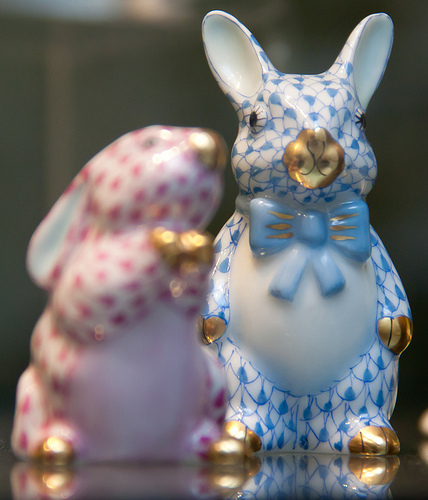<image>
Is the blue bunny in front of the pink bunny? No. The blue bunny is not in front of the pink bunny. The spatial positioning shows a different relationship between these objects. 